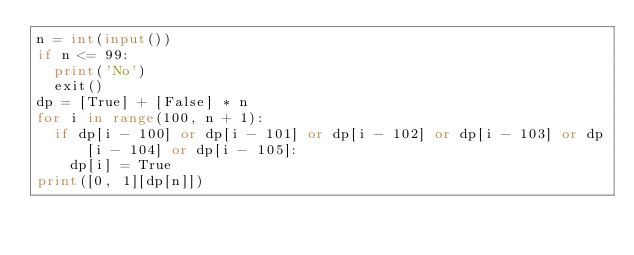Convert code to text. <code><loc_0><loc_0><loc_500><loc_500><_Python_>n = int(input())
if n <= 99:
  print('No')
  exit()
dp = [True] + [False] * n
for i in range(100, n + 1):
  if dp[i - 100] or dp[i - 101] or dp[i - 102] or dp[i - 103] or dp[i - 104] or dp[i - 105]:
    dp[i] = True
print([0, 1][dp[n]])</code> 